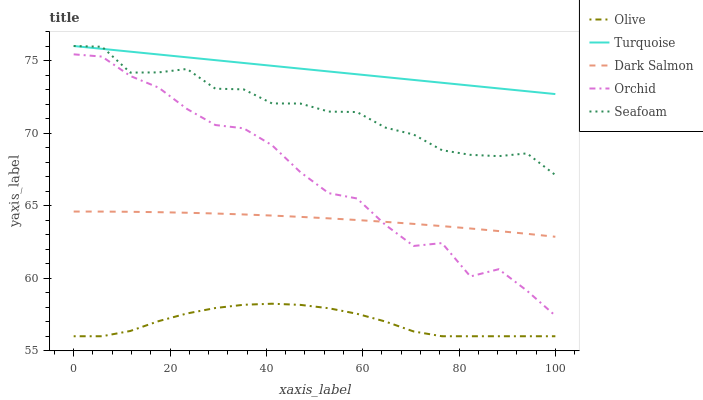Does Olive have the minimum area under the curve?
Answer yes or no. Yes. Does Turquoise have the maximum area under the curve?
Answer yes or no. Yes. Does Seafoam have the minimum area under the curve?
Answer yes or no. No. Does Seafoam have the maximum area under the curve?
Answer yes or no. No. Is Turquoise the smoothest?
Answer yes or no. Yes. Is Orchid the roughest?
Answer yes or no. Yes. Is Seafoam the smoothest?
Answer yes or no. No. Is Seafoam the roughest?
Answer yes or no. No. Does Olive have the lowest value?
Answer yes or no. Yes. Does Seafoam have the lowest value?
Answer yes or no. No. Does Seafoam have the highest value?
Answer yes or no. Yes. Does Dark Salmon have the highest value?
Answer yes or no. No. Is Orchid less than Turquoise?
Answer yes or no. Yes. Is Turquoise greater than Orchid?
Answer yes or no. Yes. Does Seafoam intersect Turquoise?
Answer yes or no. Yes. Is Seafoam less than Turquoise?
Answer yes or no. No. Is Seafoam greater than Turquoise?
Answer yes or no. No. Does Orchid intersect Turquoise?
Answer yes or no. No. 